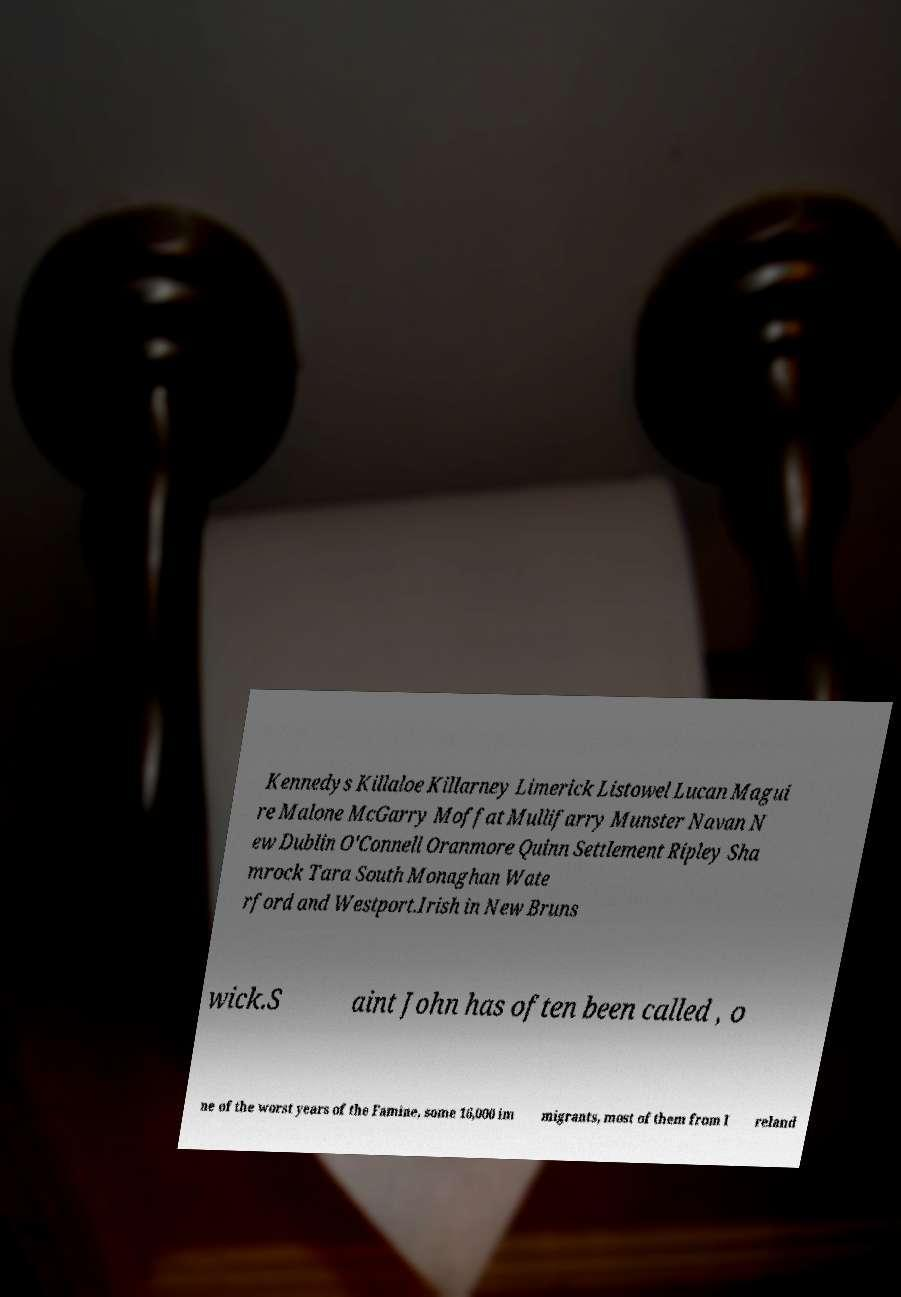Please identify and transcribe the text found in this image. Kennedys Killaloe Killarney Limerick Listowel Lucan Magui re Malone McGarry Moffat Mullifarry Munster Navan N ew Dublin O'Connell Oranmore Quinn Settlement Ripley Sha mrock Tara South Monaghan Wate rford and Westport.Irish in New Bruns wick.S aint John has often been called , o ne of the worst years of the Famine, some 16,000 im migrants, most of them from I reland 